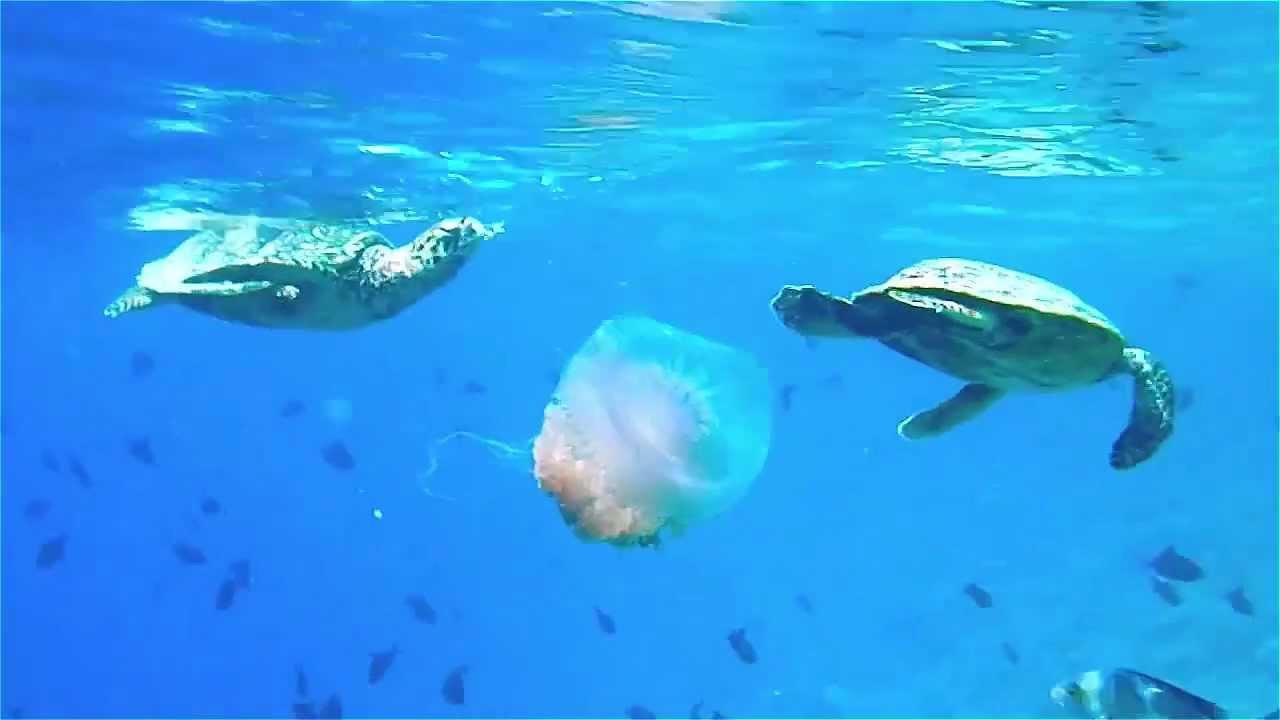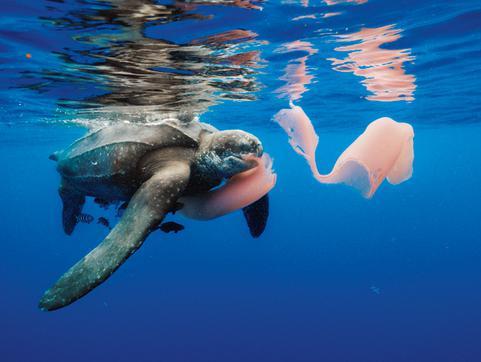The first image is the image on the left, the second image is the image on the right. Assess this claim about the two images: "A sea turtle with distinctly textured skin has its open mouth next to a purplish saucer-shaped jellyfish.". Correct or not? Answer yes or no. No. 